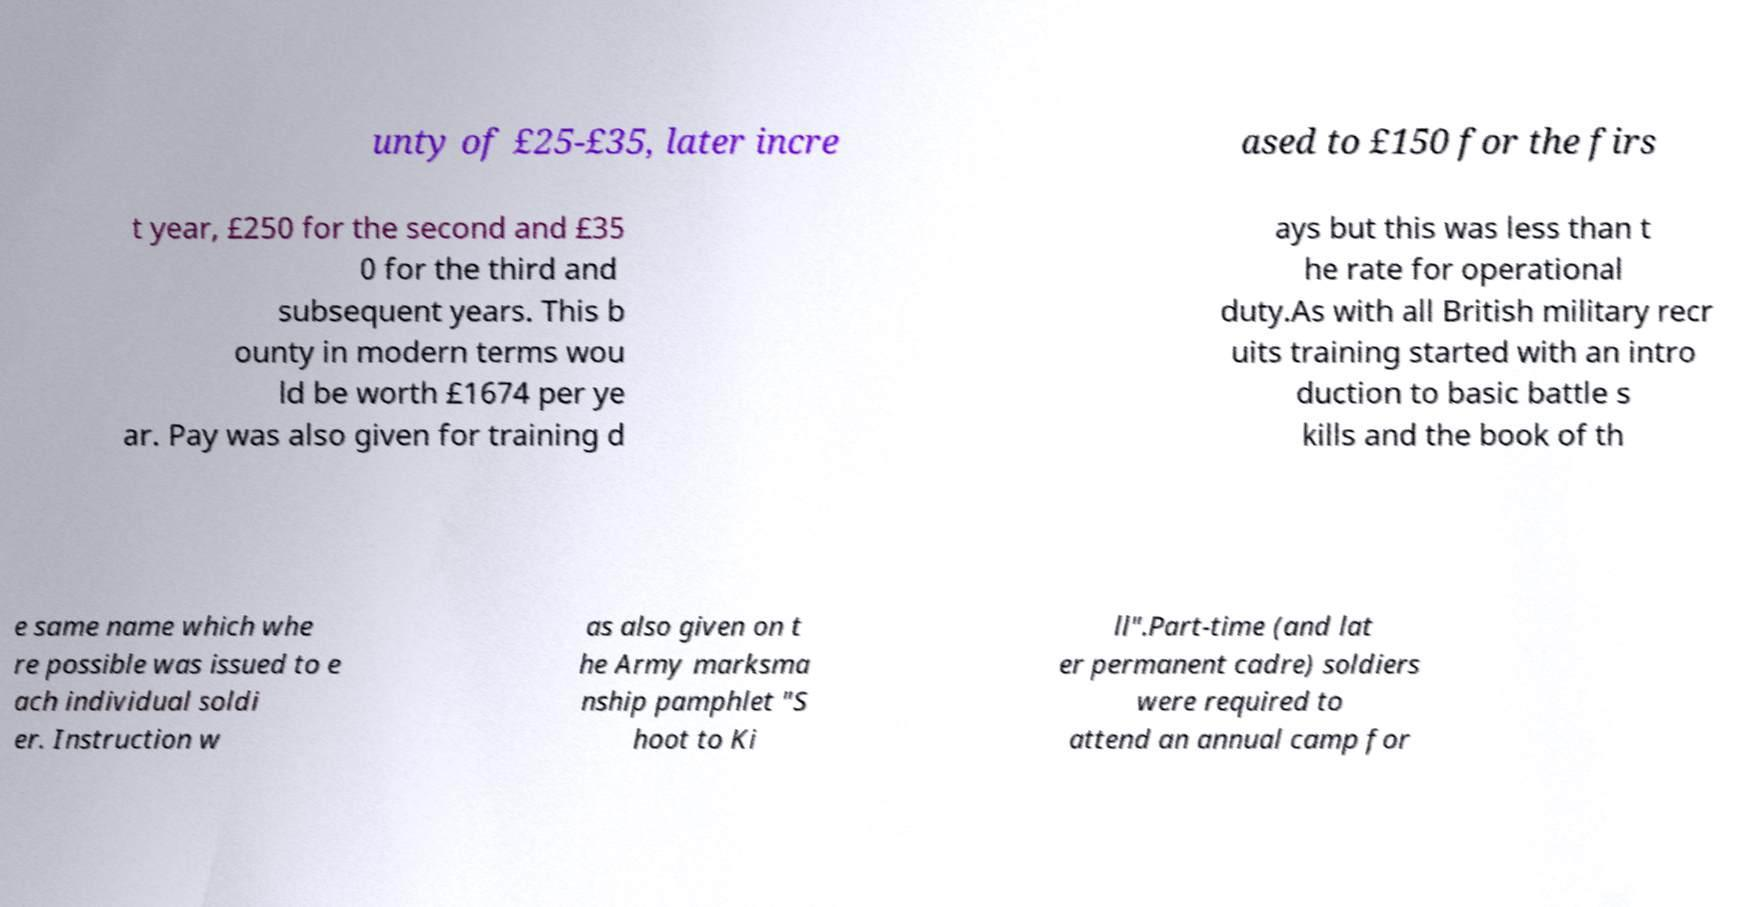For documentation purposes, I need the text within this image transcribed. Could you provide that? unty of £25-£35, later incre ased to £150 for the firs t year, £250 for the second and £35 0 for the third and subsequent years. This b ounty in modern terms wou ld be worth £1674 per ye ar. Pay was also given for training d ays but this was less than t he rate for operational duty.As with all British military recr uits training started with an intro duction to basic battle s kills and the book of th e same name which whe re possible was issued to e ach individual soldi er. Instruction w as also given on t he Army marksma nship pamphlet "S hoot to Ki ll".Part-time (and lat er permanent cadre) soldiers were required to attend an annual camp for 